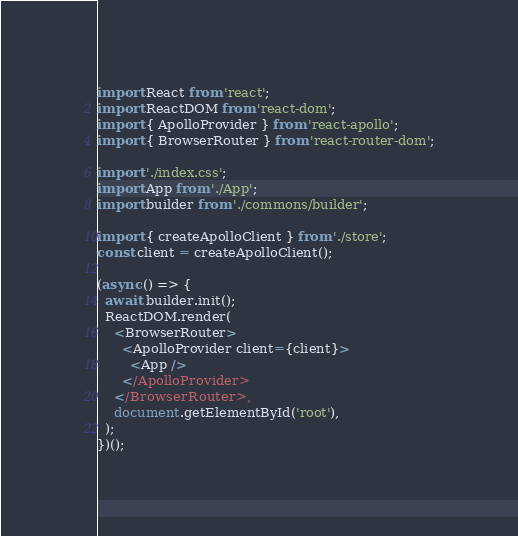<code> <loc_0><loc_0><loc_500><loc_500><_JavaScript_>import React from 'react';
import ReactDOM from 'react-dom';
import { ApolloProvider } from 'react-apollo';
import { BrowserRouter } from 'react-router-dom';

import './index.css';
import App from './App';
import builder from './commons/builder';

import { createApolloClient } from './store';
const client = createApolloClient();

(async () => {
  await builder.init();
  ReactDOM.render(
    <BrowserRouter>
      <ApolloProvider client={client}>
        <App />
      </ApolloProvider>
    </BrowserRouter>,
    document.getElementById('root'),
  );
})();
</code> 